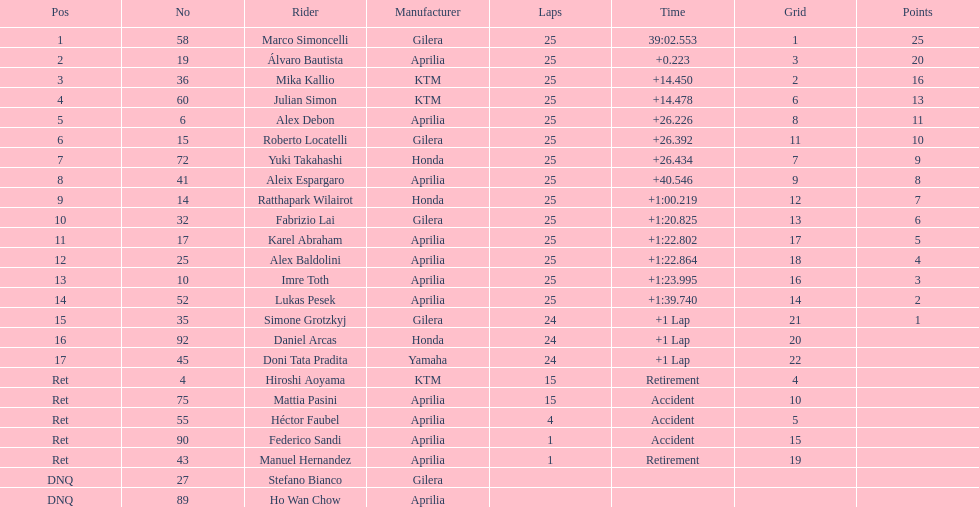The next rider from italy aside from winner marco simoncelli was Roberto Locatelli. 